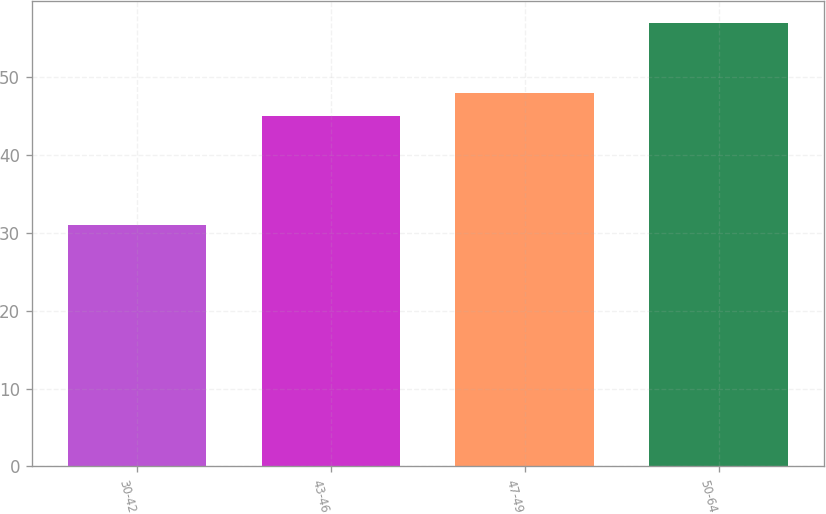<chart> <loc_0><loc_0><loc_500><loc_500><bar_chart><fcel>30-42<fcel>43-46<fcel>47-49<fcel>50-64<nl><fcel>31<fcel>45<fcel>48<fcel>57<nl></chart> 